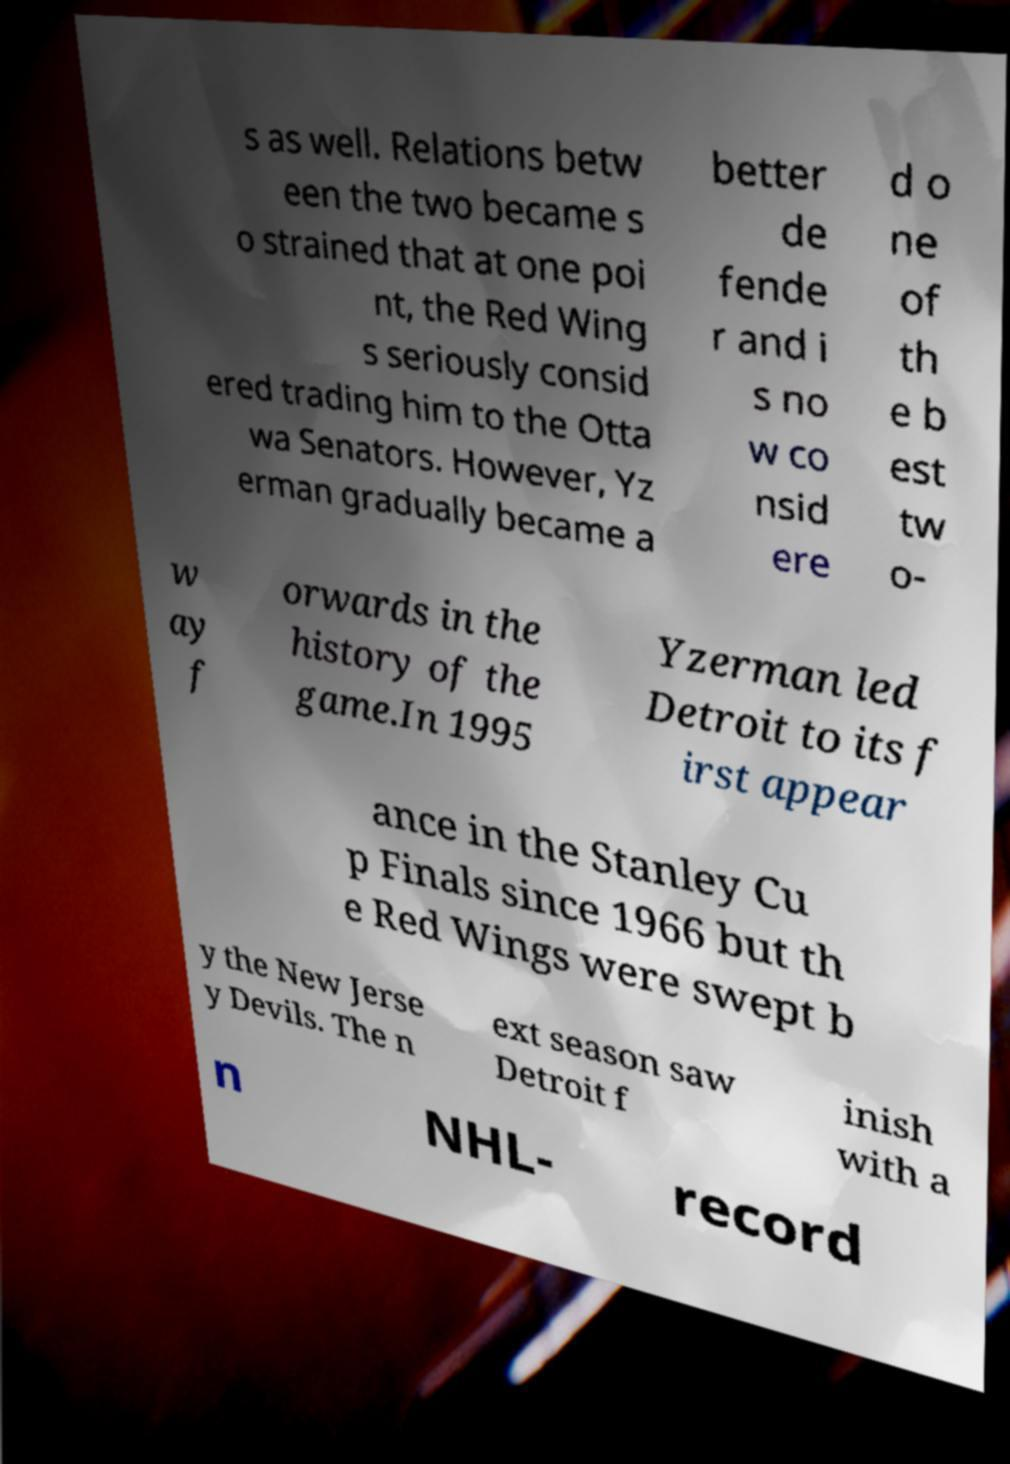Please identify and transcribe the text found in this image. s as well. Relations betw een the two became s o strained that at one poi nt, the Red Wing s seriously consid ered trading him to the Otta wa Senators. However, Yz erman gradually became a better de fende r and i s no w co nsid ere d o ne of th e b est tw o- w ay f orwards in the history of the game.In 1995 Yzerman led Detroit to its f irst appear ance in the Stanley Cu p Finals since 1966 but th e Red Wings were swept b y the New Jerse y Devils. The n ext season saw Detroit f inish with a n NHL- record 